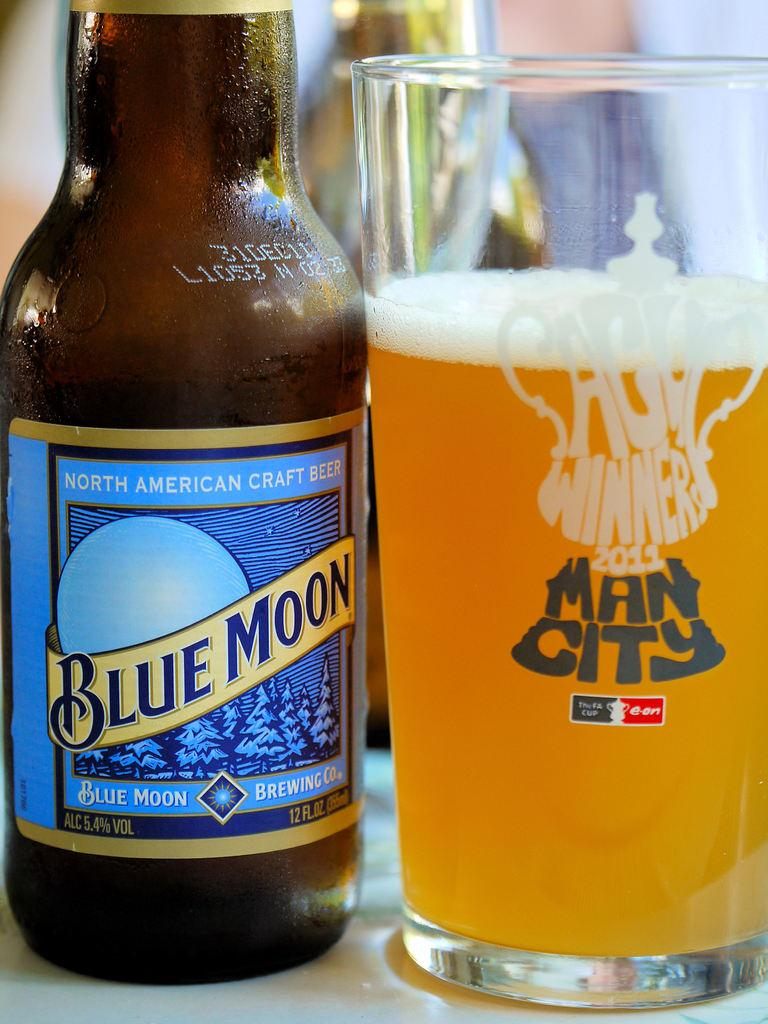<image>
Offer a succinct explanation of the picture presented. A mostly full glass of beer sits next to a Blue Moon bottle. 